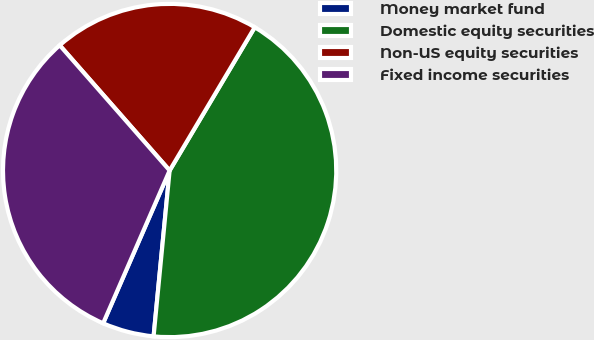Convert chart. <chart><loc_0><loc_0><loc_500><loc_500><pie_chart><fcel>Money market fund<fcel>Domestic equity securities<fcel>Non-US equity securities<fcel>Fixed income securities<nl><fcel>5.0%<fcel>43.0%<fcel>20.0%<fcel>32.0%<nl></chart> 